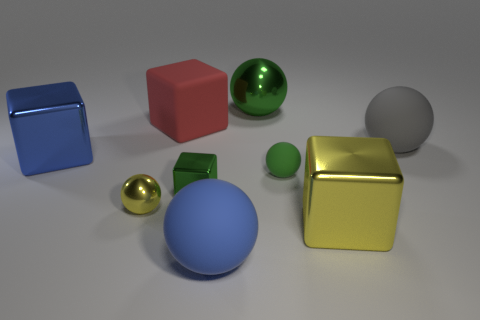Is the shape of the large gray object the same as the green metal thing behind the gray matte thing?
Offer a very short reply. Yes. How many other things are there of the same material as the red object?
Offer a very short reply. 3. There is a gray object; are there any objects on the left side of it?
Your answer should be very brief. Yes. There is a gray object; is it the same size as the yellow cube in front of the small green metal block?
Give a very brief answer. Yes. What color is the big block in front of the green shiny object in front of the big gray sphere?
Keep it short and to the point. Yellow. Is the red rubber block the same size as the yellow metallic cube?
Offer a terse response. Yes. The shiny block that is both to the right of the blue metallic cube and to the left of the blue sphere is what color?
Ensure brevity in your answer.  Green. The gray thing is what size?
Provide a short and direct response. Large. Does the big shiny thing to the left of the small green metallic object have the same color as the rubber block?
Offer a terse response. No. Is the number of large matte spheres that are on the right side of the green rubber thing greater than the number of large red rubber things that are behind the large gray matte ball?
Make the answer very short. No. 